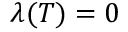<formula> <loc_0><loc_0><loc_500><loc_500>\lambda ( T ) = 0</formula> 